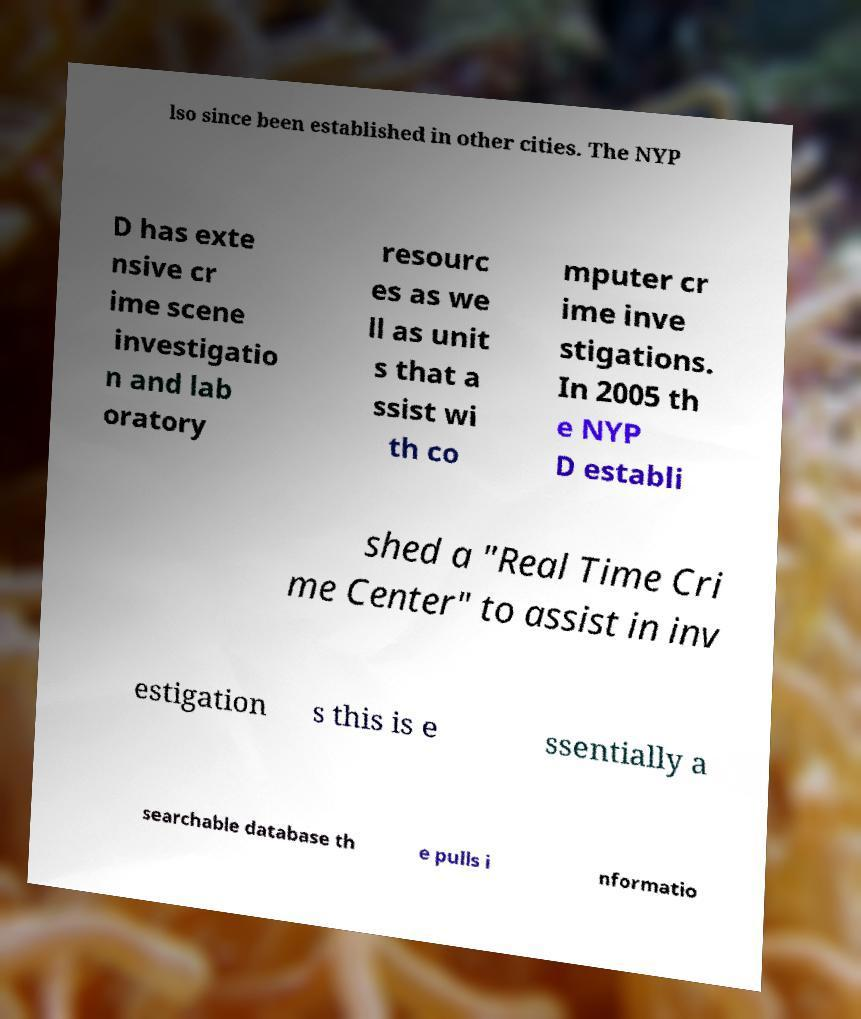For documentation purposes, I need the text within this image transcribed. Could you provide that? lso since been established in other cities. The NYP D has exte nsive cr ime scene investigatio n and lab oratory resourc es as we ll as unit s that a ssist wi th co mputer cr ime inve stigations. In 2005 th e NYP D establi shed a "Real Time Cri me Center" to assist in inv estigation s this is e ssentially a searchable database th e pulls i nformatio 